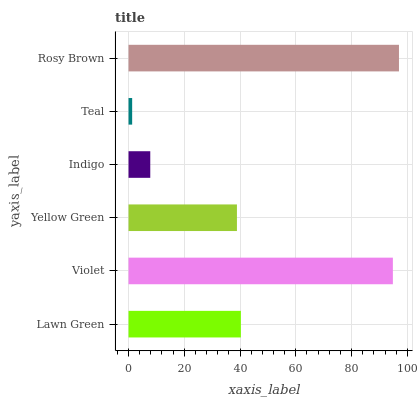Is Teal the minimum?
Answer yes or no. Yes. Is Rosy Brown the maximum?
Answer yes or no. Yes. Is Violet the minimum?
Answer yes or no. No. Is Violet the maximum?
Answer yes or no. No. Is Violet greater than Lawn Green?
Answer yes or no. Yes. Is Lawn Green less than Violet?
Answer yes or no. Yes. Is Lawn Green greater than Violet?
Answer yes or no. No. Is Violet less than Lawn Green?
Answer yes or no. No. Is Lawn Green the high median?
Answer yes or no. Yes. Is Yellow Green the low median?
Answer yes or no. Yes. Is Violet the high median?
Answer yes or no. No. Is Lawn Green the low median?
Answer yes or no. No. 